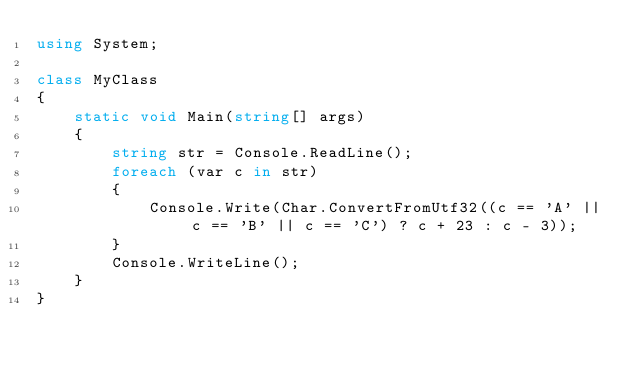Convert code to text. <code><loc_0><loc_0><loc_500><loc_500><_C#_>using System;

class MyClass
{
    static void Main(string[] args)
    {
        string str = Console.ReadLine();
        foreach (var c in str)
        {
            Console.Write(Char.ConvertFromUtf32((c == 'A' || c == 'B' || c == 'C') ? c + 23 : c - 3));
        }
        Console.WriteLine();
    }
}
</code> 